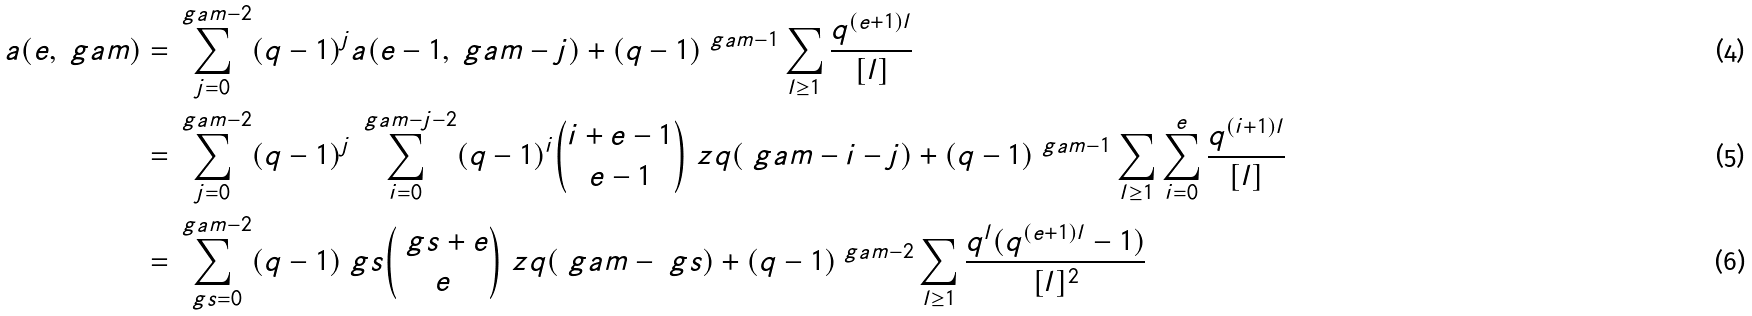Convert formula to latex. <formula><loc_0><loc_0><loc_500><loc_500>a ( e , \ g a m ) = & \sum _ { j = 0 } ^ { \ g a m - 2 } ( q - 1 ) ^ { j } a ( e - 1 , \ g a m - j ) + ( q - 1 ) ^ { \ g a m - 1 } \sum _ { l \geq 1 } \frac { q ^ { ( e + 1 ) l } } { [ l ] } \\ = & \sum _ { j = 0 } ^ { \ g a m - 2 } ( q - 1 ) ^ { j } \sum _ { i = 0 } ^ { \ g a m - j - 2 } ( q - 1 ) ^ { i } { i + e - 1 \choose e - 1 } \ z q ( \ g a m - i - j ) + ( q - 1 ) ^ { \ g a m - 1 } \sum _ { l \geq 1 } \sum _ { i = 0 } ^ { e } \frac { q ^ { ( i + 1 ) l } } { [ l ] } \\ = & \sum _ { \ g s = 0 } ^ { \ g a m - 2 } ( q - 1 ) ^ { \ } g s { \ g s + e \choose e } \ z q ( \ g a m - \ g s ) + ( q - 1 ) ^ { \ g a m - 2 } \sum _ { l \geq 1 } \frac { q ^ { l } ( q ^ { ( e + 1 ) l } - 1 ) } { [ l ] ^ { 2 } }</formula> 